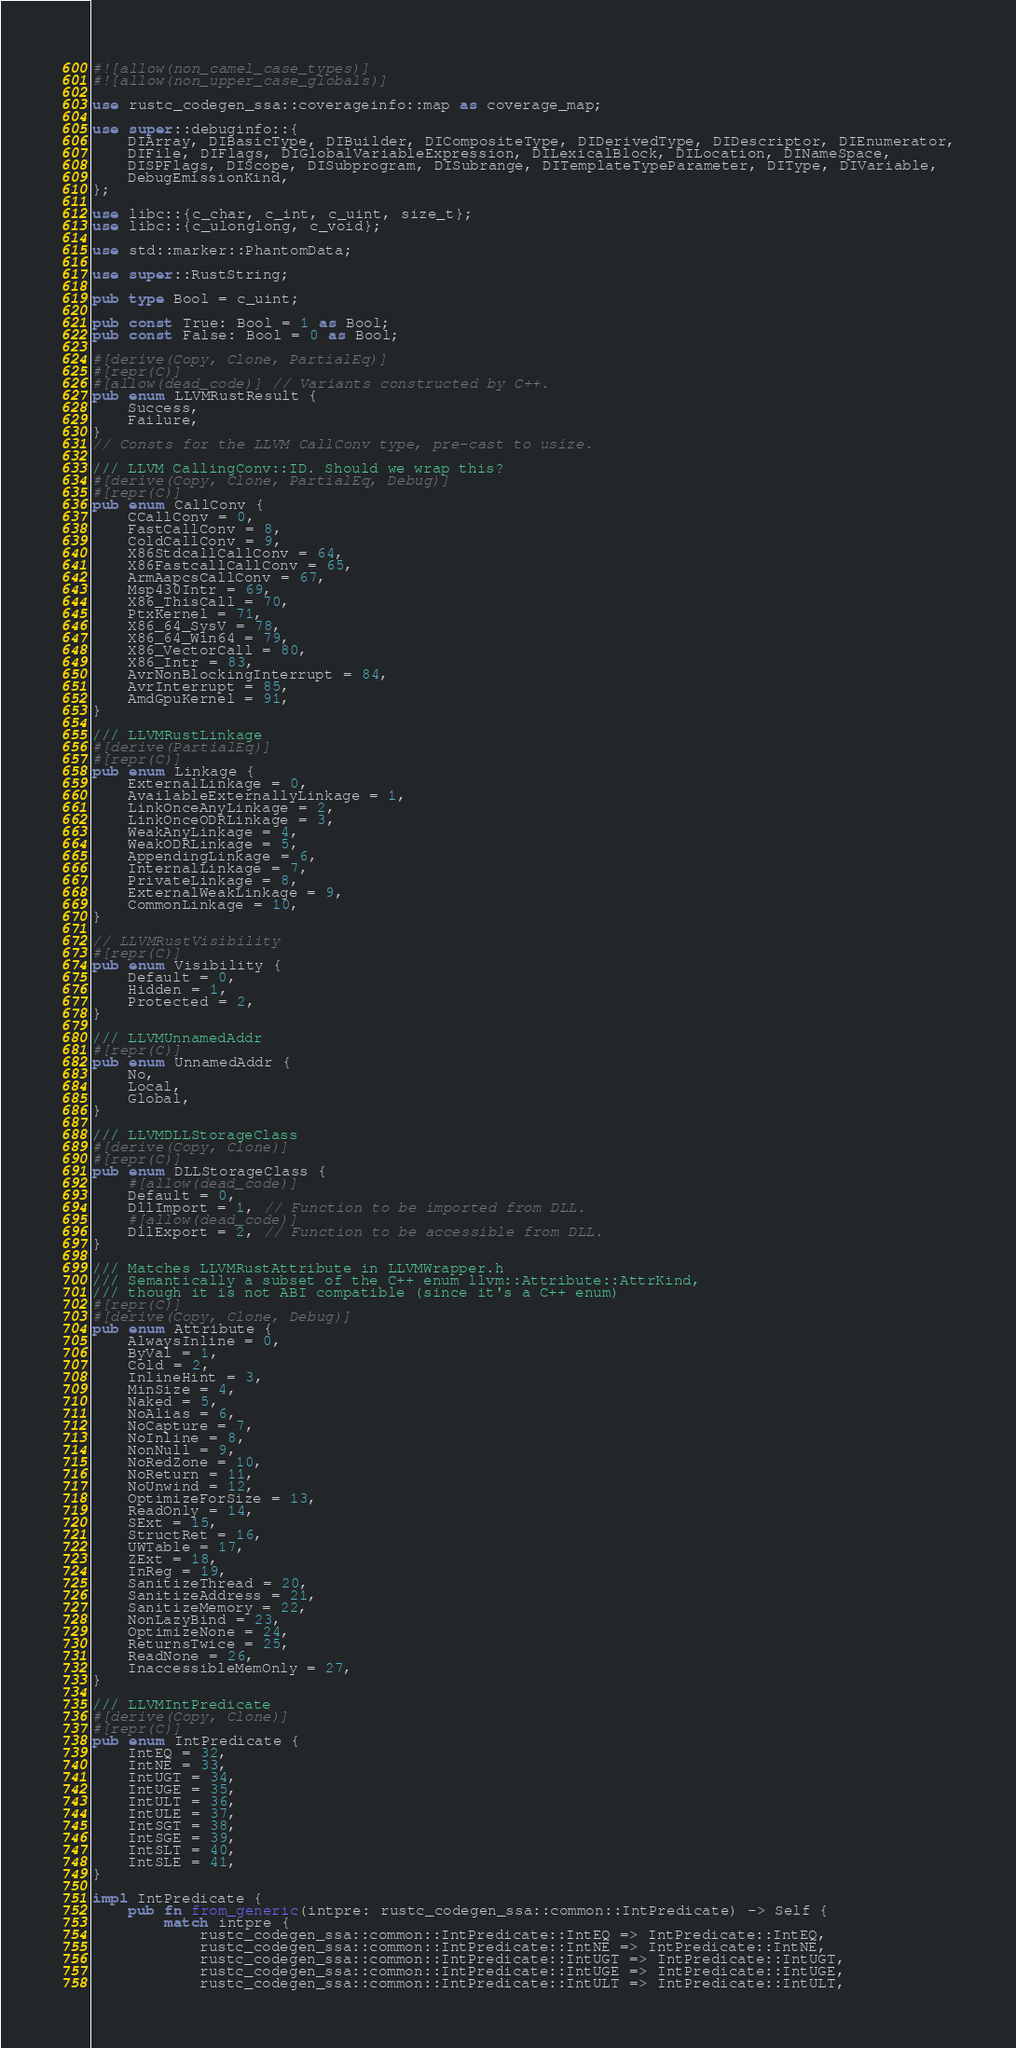<code> <loc_0><loc_0><loc_500><loc_500><_Rust_>#![allow(non_camel_case_types)]
#![allow(non_upper_case_globals)]

use rustc_codegen_ssa::coverageinfo::map as coverage_map;

use super::debuginfo::{
    DIArray, DIBasicType, DIBuilder, DICompositeType, DIDerivedType, DIDescriptor, DIEnumerator,
    DIFile, DIFlags, DIGlobalVariableExpression, DILexicalBlock, DILocation, DINameSpace,
    DISPFlags, DIScope, DISubprogram, DISubrange, DITemplateTypeParameter, DIType, DIVariable,
    DebugEmissionKind,
};

use libc::{c_char, c_int, c_uint, size_t};
use libc::{c_ulonglong, c_void};

use std::marker::PhantomData;

use super::RustString;

pub type Bool = c_uint;

pub const True: Bool = 1 as Bool;
pub const False: Bool = 0 as Bool;

#[derive(Copy, Clone, PartialEq)]
#[repr(C)]
#[allow(dead_code)] // Variants constructed by C++.
pub enum LLVMRustResult {
    Success,
    Failure,
}
// Consts for the LLVM CallConv type, pre-cast to usize.

/// LLVM CallingConv::ID. Should we wrap this?
#[derive(Copy, Clone, PartialEq, Debug)]
#[repr(C)]
pub enum CallConv {
    CCallConv = 0,
    FastCallConv = 8,
    ColdCallConv = 9,
    X86StdcallCallConv = 64,
    X86FastcallCallConv = 65,
    ArmAapcsCallConv = 67,
    Msp430Intr = 69,
    X86_ThisCall = 70,
    PtxKernel = 71,
    X86_64_SysV = 78,
    X86_64_Win64 = 79,
    X86_VectorCall = 80,
    X86_Intr = 83,
    AvrNonBlockingInterrupt = 84,
    AvrInterrupt = 85,
    AmdGpuKernel = 91,
}

/// LLVMRustLinkage
#[derive(PartialEq)]
#[repr(C)]
pub enum Linkage {
    ExternalLinkage = 0,
    AvailableExternallyLinkage = 1,
    LinkOnceAnyLinkage = 2,
    LinkOnceODRLinkage = 3,
    WeakAnyLinkage = 4,
    WeakODRLinkage = 5,
    AppendingLinkage = 6,
    InternalLinkage = 7,
    PrivateLinkage = 8,
    ExternalWeakLinkage = 9,
    CommonLinkage = 10,
}

// LLVMRustVisibility
#[repr(C)]
pub enum Visibility {
    Default = 0,
    Hidden = 1,
    Protected = 2,
}

/// LLVMUnnamedAddr
#[repr(C)]
pub enum UnnamedAddr {
    No,
    Local,
    Global,
}

/// LLVMDLLStorageClass
#[derive(Copy, Clone)]
#[repr(C)]
pub enum DLLStorageClass {
    #[allow(dead_code)]
    Default = 0,
    DllImport = 1, // Function to be imported from DLL.
    #[allow(dead_code)]
    DllExport = 2, // Function to be accessible from DLL.
}

/// Matches LLVMRustAttribute in LLVMWrapper.h
/// Semantically a subset of the C++ enum llvm::Attribute::AttrKind,
/// though it is not ABI compatible (since it's a C++ enum)
#[repr(C)]
#[derive(Copy, Clone, Debug)]
pub enum Attribute {
    AlwaysInline = 0,
    ByVal = 1,
    Cold = 2,
    InlineHint = 3,
    MinSize = 4,
    Naked = 5,
    NoAlias = 6,
    NoCapture = 7,
    NoInline = 8,
    NonNull = 9,
    NoRedZone = 10,
    NoReturn = 11,
    NoUnwind = 12,
    OptimizeForSize = 13,
    ReadOnly = 14,
    SExt = 15,
    StructRet = 16,
    UWTable = 17,
    ZExt = 18,
    InReg = 19,
    SanitizeThread = 20,
    SanitizeAddress = 21,
    SanitizeMemory = 22,
    NonLazyBind = 23,
    OptimizeNone = 24,
    ReturnsTwice = 25,
    ReadNone = 26,
    InaccessibleMemOnly = 27,
}

/// LLVMIntPredicate
#[derive(Copy, Clone)]
#[repr(C)]
pub enum IntPredicate {
    IntEQ = 32,
    IntNE = 33,
    IntUGT = 34,
    IntUGE = 35,
    IntULT = 36,
    IntULE = 37,
    IntSGT = 38,
    IntSGE = 39,
    IntSLT = 40,
    IntSLE = 41,
}

impl IntPredicate {
    pub fn from_generic(intpre: rustc_codegen_ssa::common::IntPredicate) -> Self {
        match intpre {
            rustc_codegen_ssa::common::IntPredicate::IntEQ => IntPredicate::IntEQ,
            rustc_codegen_ssa::common::IntPredicate::IntNE => IntPredicate::IntNE,
            rustc_codegen_ssa::common::IntPredicate::IntUGT => IntPredicate::IntUGT,
            rustc_codegen_ssa::common::IntPredicate::IntUGE => IntPredicate::IntUGE,
            rustc_codegen_ssa::common::IntPredicate::IntULT => IntPredicate::IntULT,</code> 